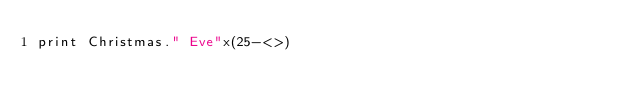<code> <loc_0><loc_0><loc_500><loc_500><_Perl_>print Christmas." Eve"x(25-<>)</code> 